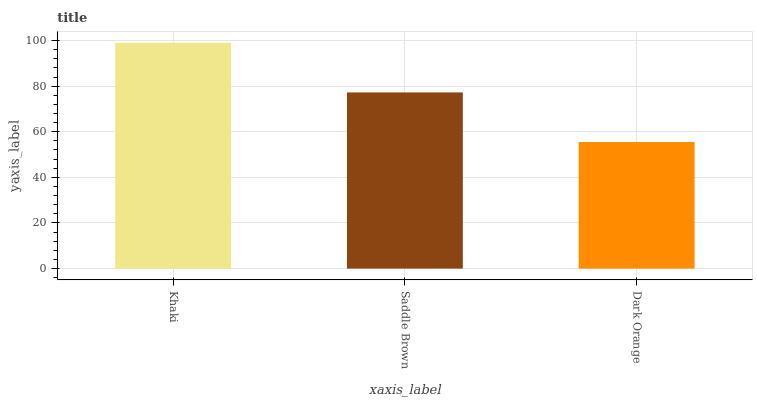Is Dark Orange the minimum?
Answer yes or no. Yes. Is Khaki the maximum?
Answer yes or no. Yes. Is Saddle Brown the minimum?
Answer yes or no. No. Is Saddle Brown the maximum?
Answer yes or no. No. Is Khaki greater than Saddle Brown?
Answer yes or no. Yes. Is Saddle Brown less than Khaki?
Answer yes or no. Yes. Is Saddle Brown greater than Khaki?
Answer yes or no. No. Is Khaki less than Saddle Brown?
Answer yes or no. No. Is Saddle Brown the high median?
Answer yes or no. Yes. Is Saddle Brown the low median?
Answer yes or no. Yes. Is Khaki the high median?
Answer yes or no. No. Is Dark Orange the low median?
Answer yes or no. No. 